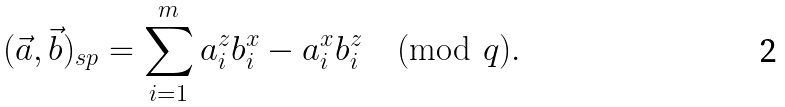Convert formula to latex. <formula><loc_0><loc_0><loc_500><loc_500>( \vec { a } , \vec { b } ) _ { s p } = \sum _ { i = 1 } ^ { m } a ^ { z } _ { i } b ^ { x } _ { i } - a ^ { x } _ { i } b ^ { z } _ { i } \pmod { q } .</formula> 